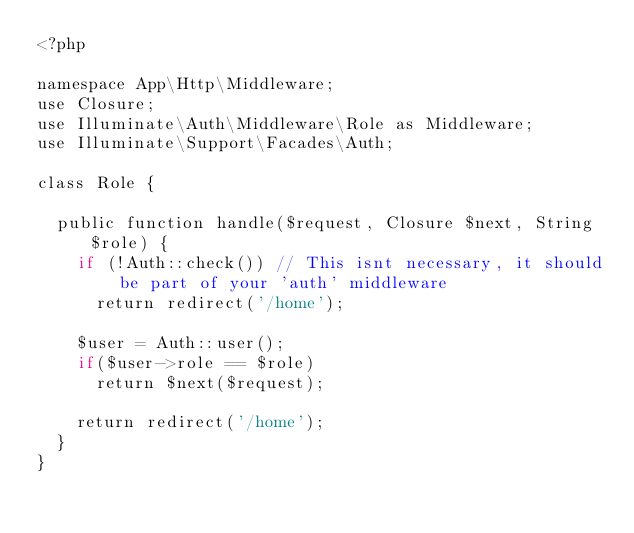<code> <loc_0><loc_0><loc_500><loc_500><_PHP_><?php

namespace App\Http\Middleware;
use Closure;
use Illuminate\Auth\Middleware\Role as Middleware;
use Illuminate\Support\Facades\Auth;

class Role {

  public function handle($request, Closure $next, String $role) {
    if (!Auth::check()) // This isnt necessary, it should be part of your 'auth' middleware
      return redirect('/home');

    $user = Auth::user();
    if($user->role == $role)
      return $next($request);

    return redirect('/home');
  }
}</code> 